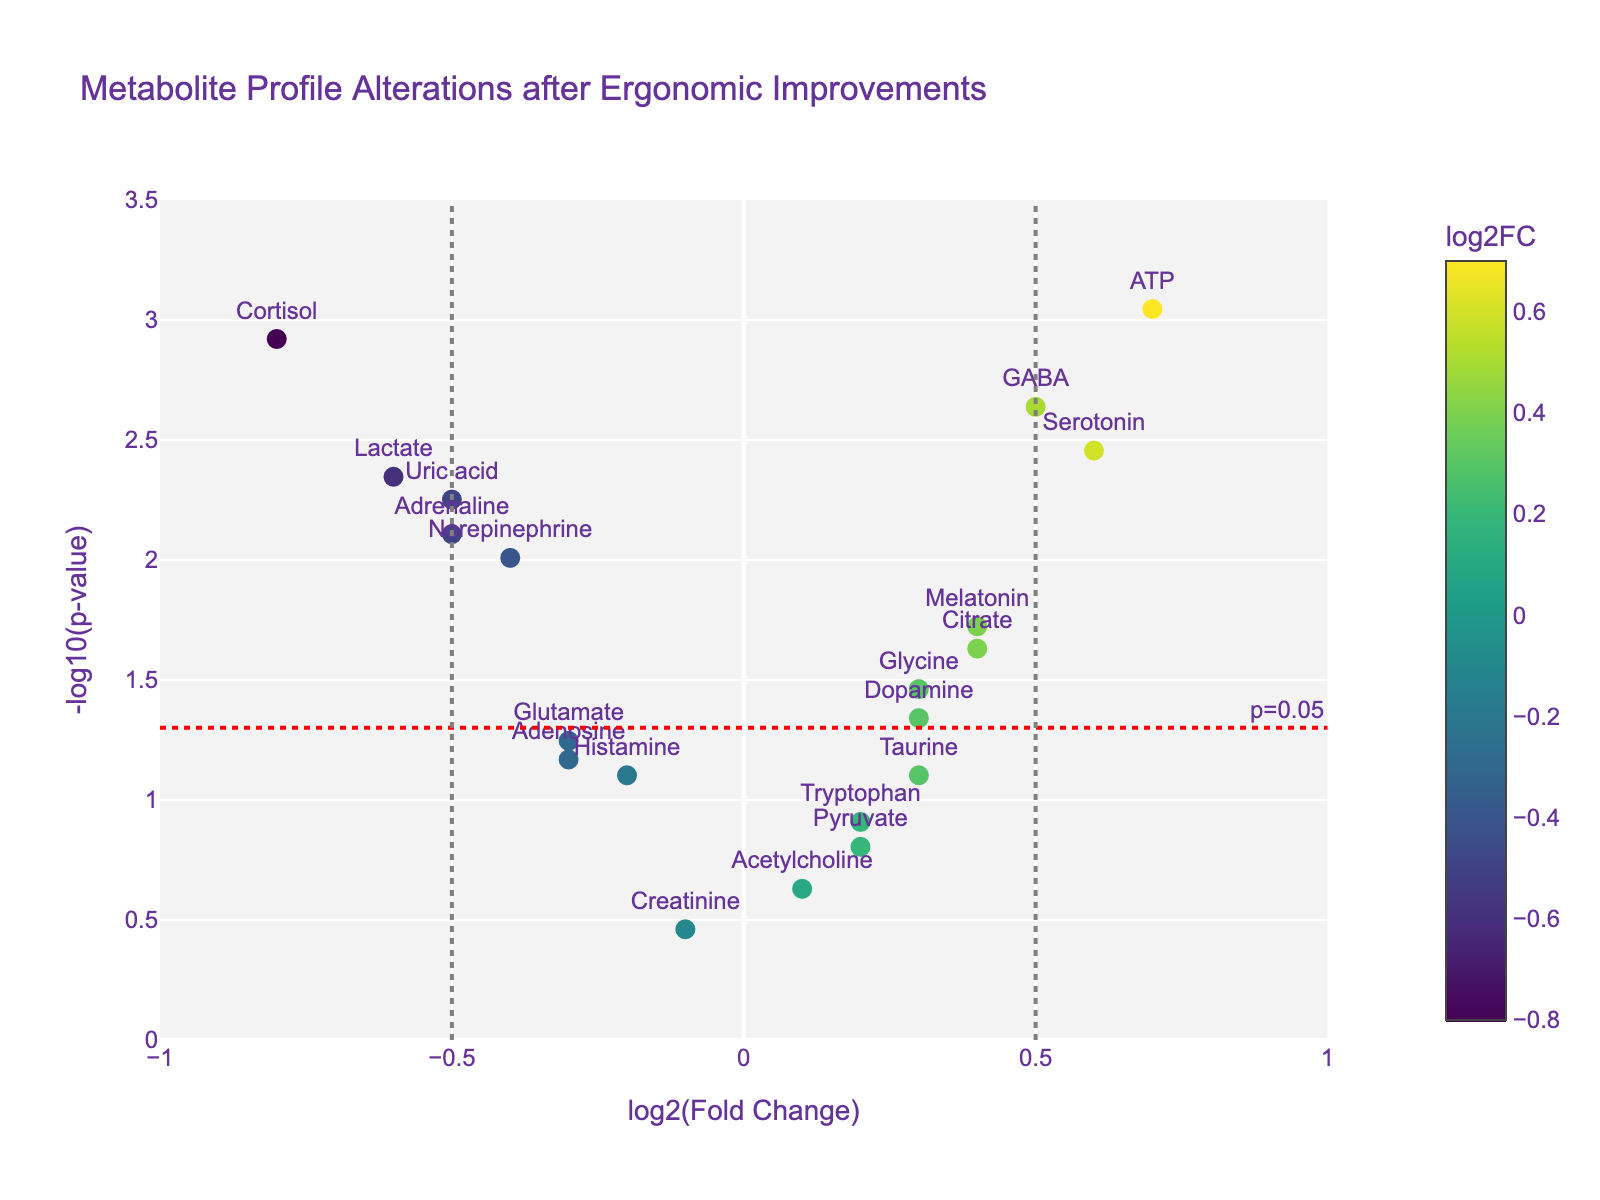What is the title of the plot? The title is located at the top of the plot. It is clearly stated as "Metabolite Profile Alterations after Ergonomic Improvements".
Answer: Metabolite Profile Alterations after Ergonomic Improvements How many metabolites have a log2(Fold Change) less than -0.5? Visual inspection shows that data points with log2(Fold Change) less than -0.5 are labeled and placed on the left side of the vertical gray line at -0.5. Only Cortisol falls into this category.
Answer: 1 Which metabolite has the highest positive log2(Fold Change)? By looking at the x-axis and finding the highest value on the right side of the plot, ATP is the metabolite with the highest positive log2(Fold Change) of 0.7.
Answer: ATP What is the significance threshold shown by the horizontal red line? The red dashed horizontal line is labeled "p=0.05", indicating the significance threshold at -log10(p-value). The -log10(0.05) equals approximately 1.3.
Answer: -log10(0.05) Which metabolites have p-values below the threshold of 0.05? Metabolites below the horizontal red dashed line (representing p=0.05) have p-values below 0.05. They include Cortisol, Serotonin, Melatonin, Adrenaline, GABA, Norepinephrine, Lactate, ATP, Citrate, Glycine, and Uric acid.
Answer: 11 Which metabolite has the smallest p-value? By identifying the highest point on the y-axis, which represents the smallest p-value (highest -log10(p-value) value), ATP has the smallest p-value of 0.0009.
Answer: ATP Are there any metabolites with non-significant p-values and a log2(Fold Change) greater than 0.1? Non-significant p-values (>0.05) are those under the red dashed line. Metabolites within this criteria and with log2(Fold Change) > 0.1 are Tryptophan, Acetylcholine, Taurine, and Pyruvate.
Answer: 4 What is the log2(Fold Change) and p-value for Serotonin? Hovering or inspecting the plot near the label "Serotonin" shows its log2(Fold Change) is 0.6 and p-value is 0.0035.
Answer: 0.6, 0.0035 How many metabolites have a log2(Fold Change) between -0.5 and 0.5? Visual inspection and counting of points within the range -0.5 < x < 0.5 shows that there are metabolites Tryptophan, Glutamate, Dopamine, Histamine, Glycine, and Acetylcholine. This equates to six metabolites.
Answer: 6 